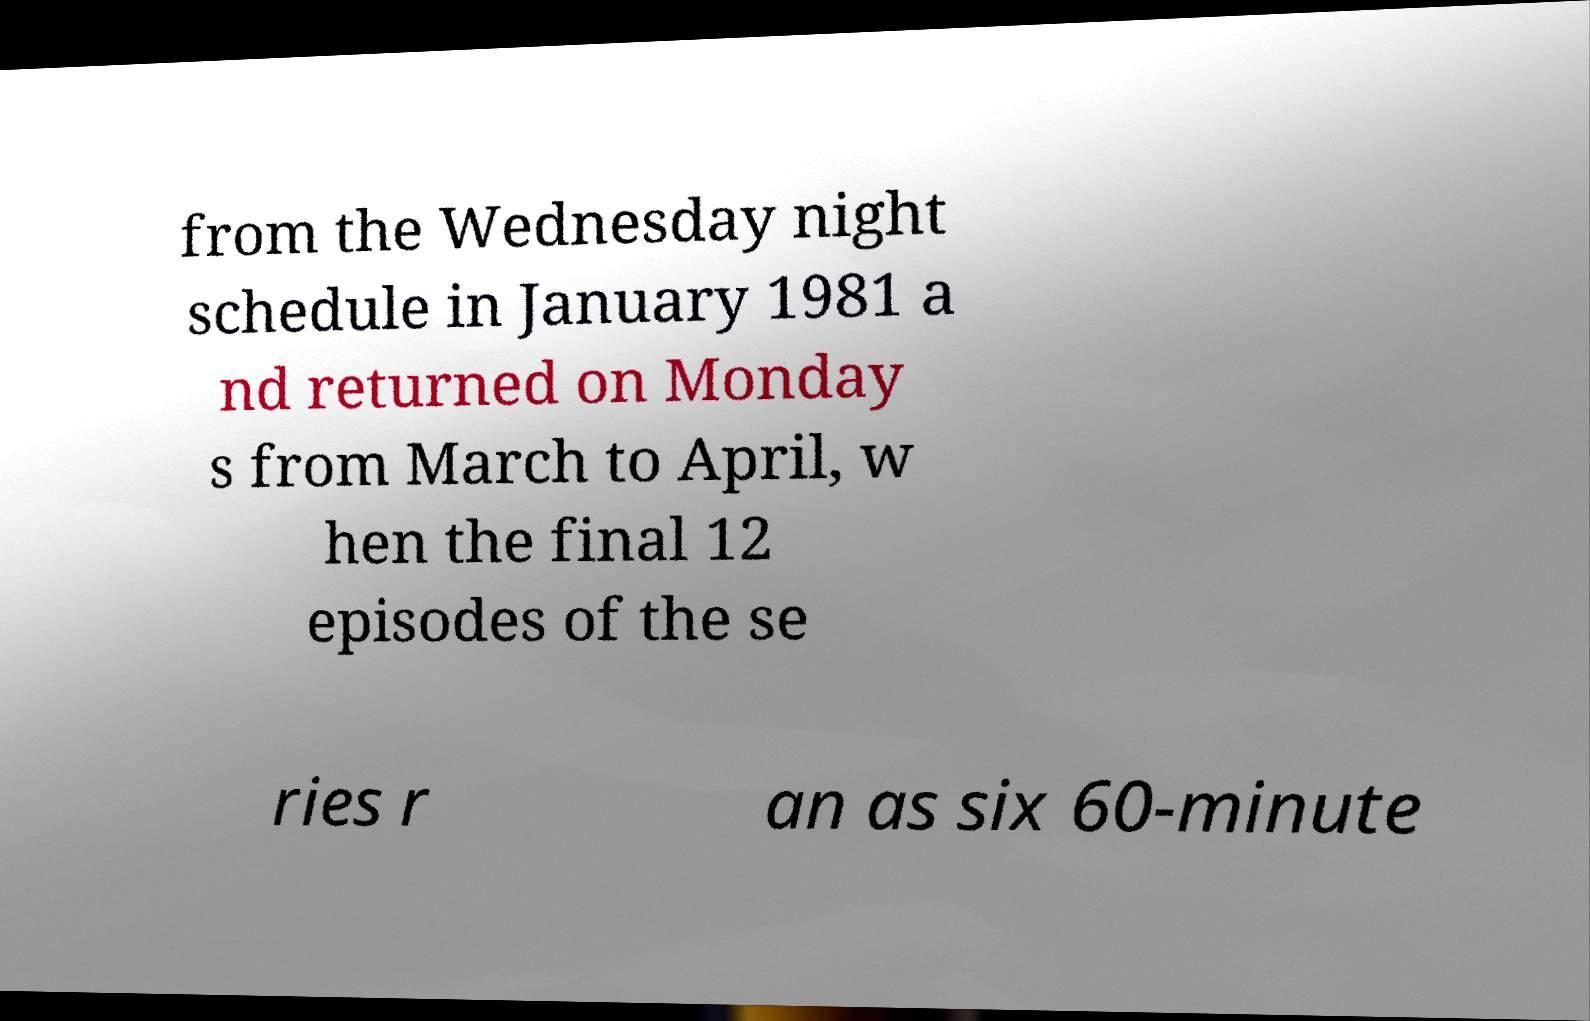For documentation purposes, I need the text within this image transcribed. Could you provide that? from the Wednesday night schedule in January 1981 a nd returned on Monday s from March to April, w hen the final 12 episodes of the se ries r an as six 60-minute 